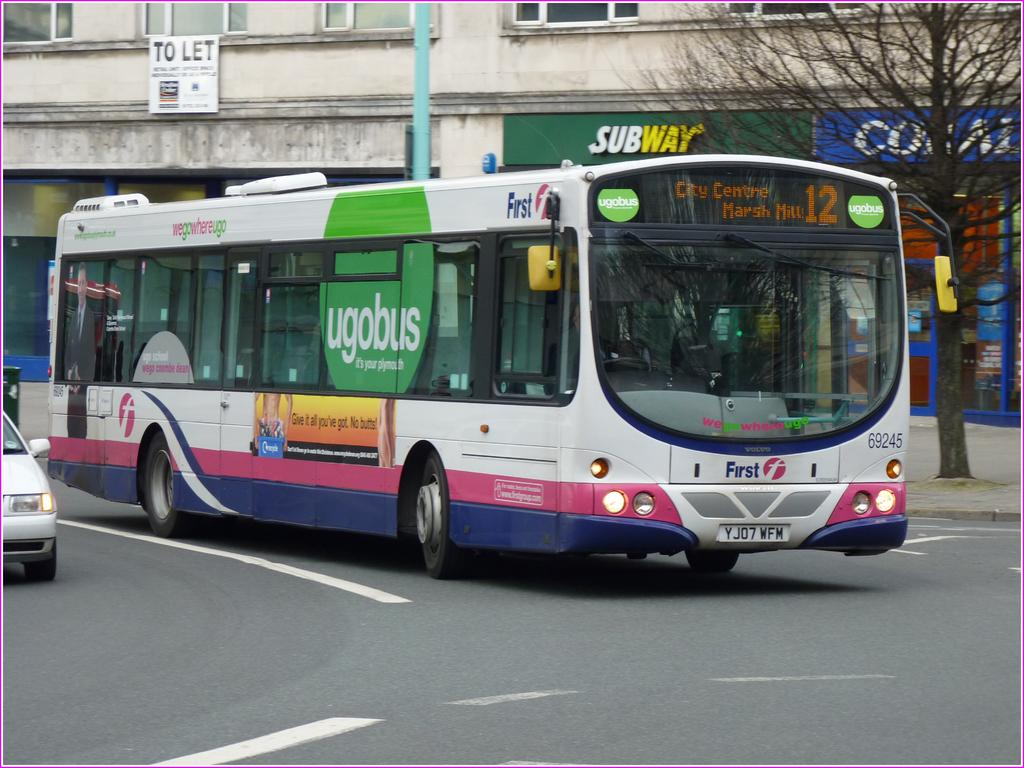<image>
Give a short and clear explanation of the subsequent image. bus number 12 going to city centre, marsh mills 